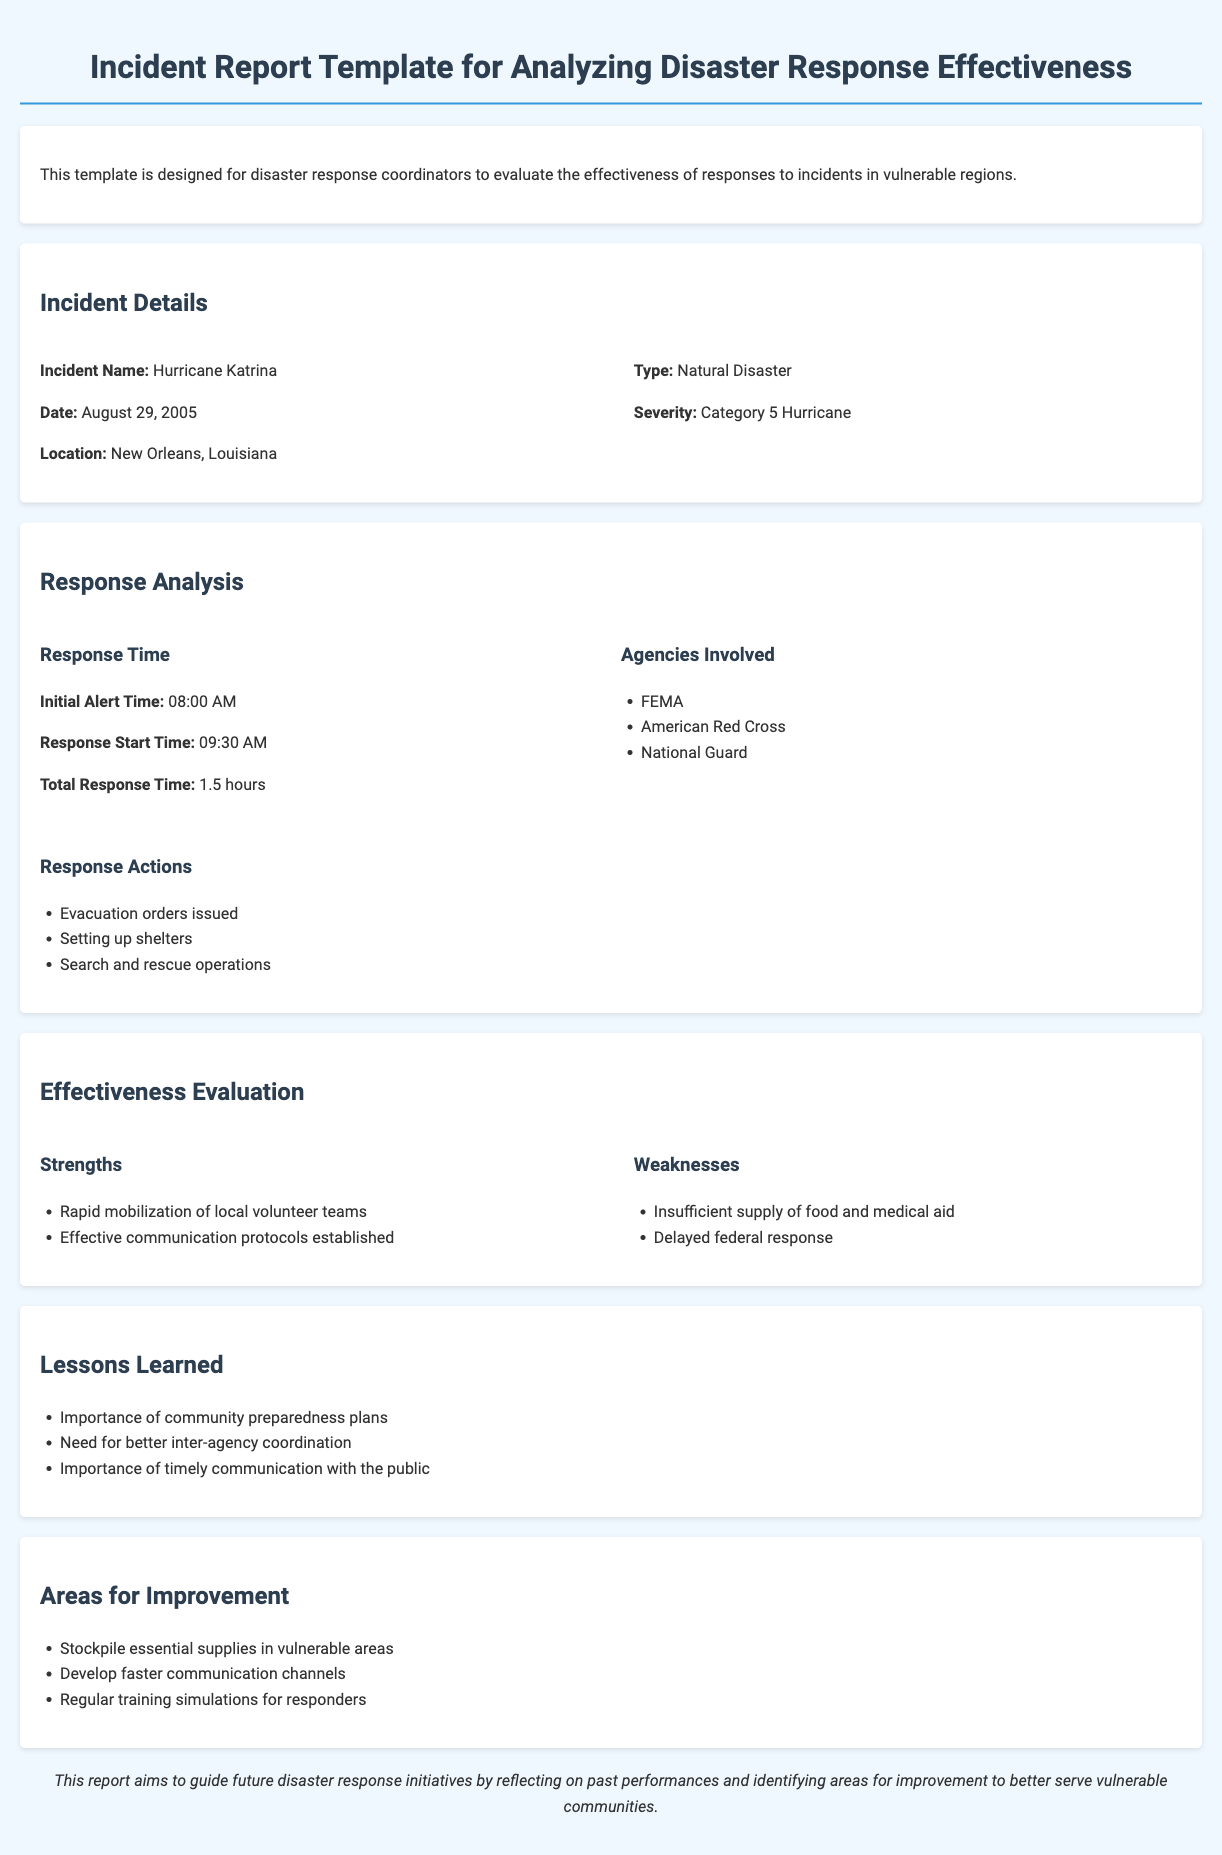What is the incident name? The incident name is stated in the document under the Incident Details section.
Answer: Hurricane Katrina When did the incident occur? The date of the incident is listed in the Incident Details section.
Answer: August 29, 2005 What was the total response time? The total response time is calculated from the initial alert to response start time.
Answer: 1.5 hours Which agency is listed first among those involved? The agencies involved are listed under the Response Analysis section, in bullet points.
Answer: FEMA What was identified as a strength in the response evaluation? Strengths are outlined in the Effectiveness Evaluation section.
Answer: Rapid mobilization of local volunteer teams What is one identified area for improvement? Areas for improvement can be found in the Areas for Improvement section.
Answer: Stockpile essential supplies in vulnerable areas What type of disaster was Hurricane Katrina categorized as? The category of the disaster is mentioned under Incident Details.
Answer: Natural Disaster What lesson learned emphasizes public communication? Lessons learned are presented in a bullet-point list, mentioning that importance.
Answer: Importance of timely communication with the public Who issued evacuation orders? The response actions taken during the incident are outlined in the Response Analysis section.
Answer: Evacuation orders issued 